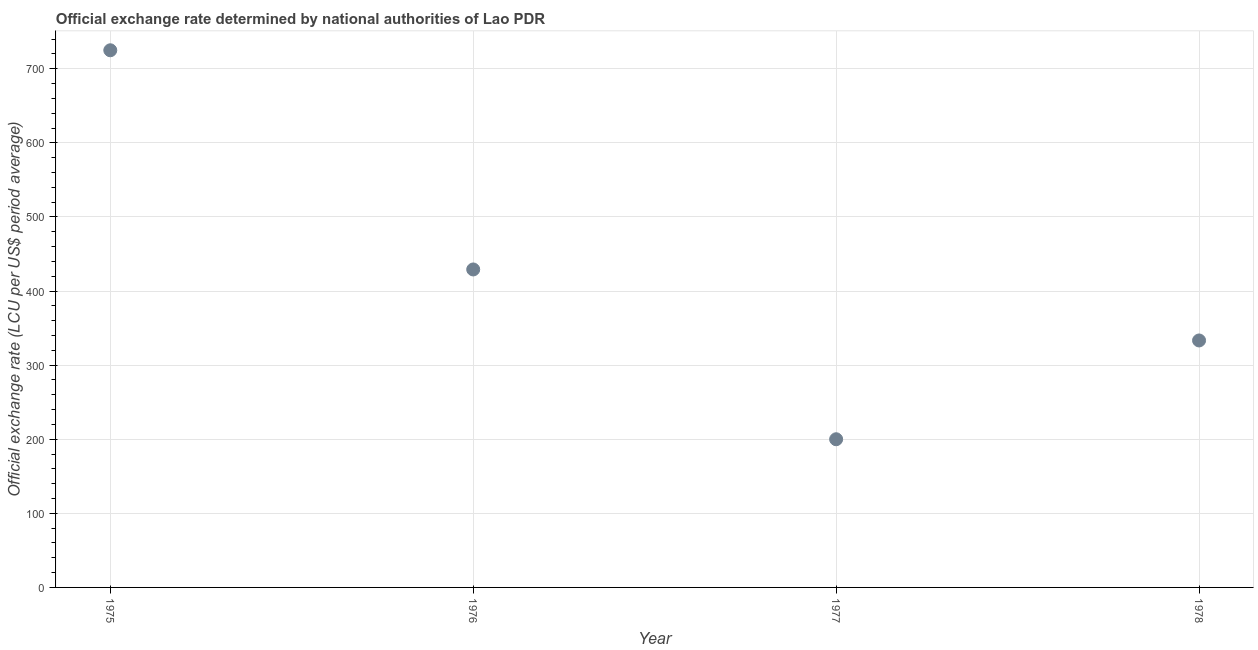What is the official exchange rate in 1975?
Provide a succinct answer. 725. Across all years, what is the maximum official exchange rate?
Offer a very short reply. 725. Across all years, what is the minimum official exchange rate?
Keep it short and to the point. 200. In which year was the official exchange rate maximum?
Offer a very short reply. 1975. In which year was the official exchange rate minimum?
Ensure brevity in your answer.  1977. What is the sum of the official exchange rate?
Keep it short and to the point. 1687.5. What is the difference between the official exchange rate in 1975 and 1978?
Make the answer very short. 391.67. What is the average official exchange rate per year?
Ensure brevity in your answer.  421.88. What is the median official exchange rate?
Give a very brief answer. 381.25. In how many years, is the official exchange rate greater than 280 ?
Offer a very short reply. 3. What is the ratio of the official exchange rate in 1975 to that in 1977?
Offer a very short reply. 3.63. What is the difference between the highest and the second highest official exchange rate?
Your answer should be very brief. 295.83. What is the difference between the highest and the lowest official exchange rate?
Your response must be concise. 525. In how many years, is the official exchange rate greater than the average official exchange rate taken over all years?
Your answer should be very brief. 2. Does the official exchange rate monotonically increase over the years?
Provide a short and direct response. No. How many dotlines are there?
Your response must be concise. 1. What is the difference between two consecutive major ticks on the Y-axis?
Provide a short and direct response. 100. Does the graph contain any zero values?
Provide a short and direct response. No. Does the graph contain grids?
Offer a very short reply. Yes. What is the title of the graph?
Provide a short and direct response. Official exchange rate determined by national authorities of Lao PDR. What is the label or title of the X-axis?
Give a very brief answer. Year. What is the label or title of the Y-axis?
Ensure brevity in your answer.  Official exchange rate (LCU per US$ period average). What is the Official exchange rate (LCU per US$ period average) in 1975?
Keep it short and to the point. 725. What is the Official exchange rate (LCU per US$ period average) in 1976?
Give a very brief answer. 429.17. What is the Official exchange rate (LCU per US$ period average) in 1977?
Provide a succinct answer. 200. What is the Official exchange rate (LCU per US$ period average) in 1978?
Provide a short and direct response. 333.33. What is the difference between the Official exchange rate (LCU per US$ period average) in 1975 and 1976?
Provide a short and direct response. 295.83. What is the difference between the Official exchange rate (LCU per US$ period average) in 1975 and 1977?
Keep it short and to the point. 525. What is the difference between the Official exchange rate (LCU per US$ period average) in 1975 and 1978?
Give a very brief answer. 391.67. What is the difference between the Official exchange rate (LCU per US$ period average) in 1976 and 1977?
Provide a short and direct response. 229.17. What is the difference between the Official exchange rate (LCU per US$ period average) in 1976 and 1978?
Your answer should be very brief. 95.83. What is the difference between the Official exchange rate (LCU per US$ period average) in 1977 and 1978?
Ensure brevity in your answer.  -133.33. What is the ratio of the Official exchange rate (LCU per US$ period average) in 1975 to that in 1976?
Provide a succinct answer. 1.69. What is the ratio of the Official exchange rate (LCU per US$ period average) in 1975 to that in 1977?
Your answer should be compact. 3.62. What is the ratio of the Official exchange rate (LCU per US$ period average) in 1975 to that in 1978?
Give a very brief answer. 2.17. What is the ratio of the Official exchange rate (LCU per US$ period average) in 1976 to that in 1977?
Give a very brief answer. 2.15. What is the ratio of the Official exchange rate (LCU per US$ period average) in 1976 to that in 1978?
Make the answer very short. 1.29. What is the ratio of the Official exchange rate (LCU per US$ period average) in 1977 to that in 1978?
Provide a succinct answer. 0.6. 